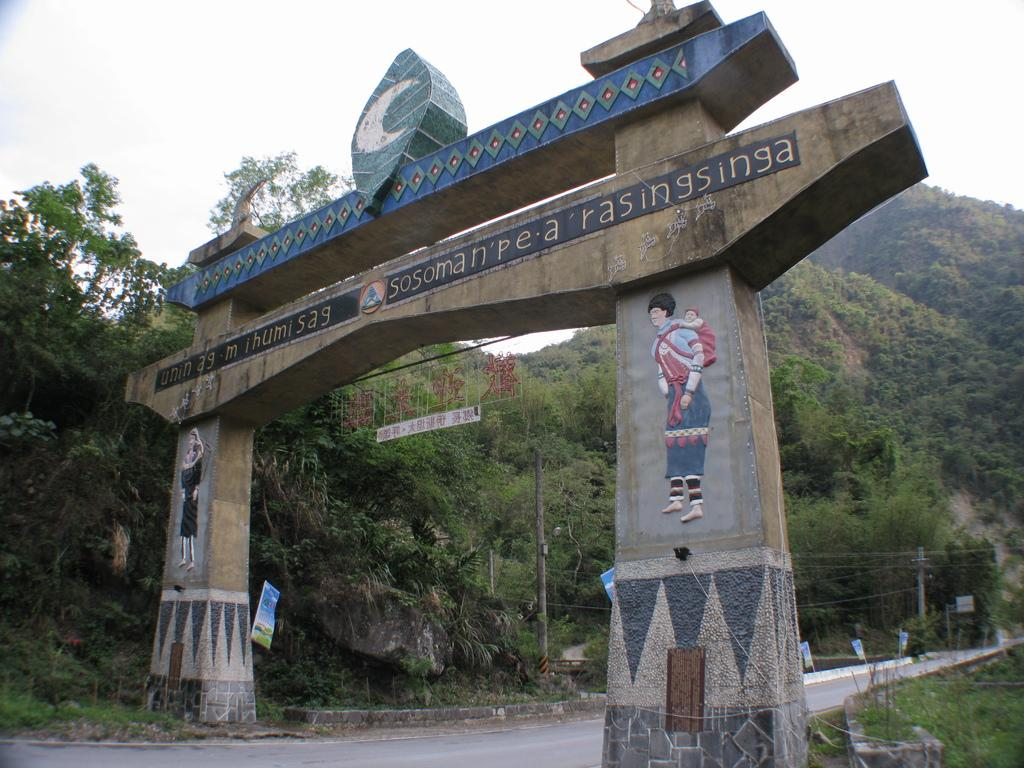What is the main subject of the image? There is a monument in the image. Where is the monument located? The monument is on a road. What can be seen in the background of the image? There are trees, mountains, and the sky visible in the background of the image. How many pins are attached to the monument in the image? There is no mention of pins in the image, so it is impossible to determine how many there are. 